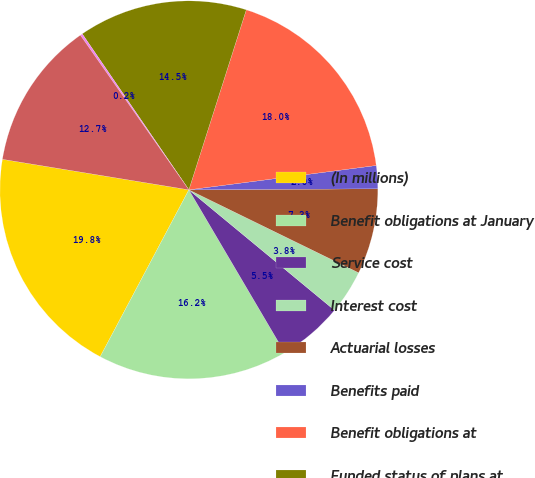Convert chart. <chart><loc_0><loc_0><loc_500><loc_500><pie_chart><fcel>(In millions)<fcel>Benefit obligations at January<fcel>Service cost<fcel>Interest cost<fcel>Actuarial losses<fcel>Benefits paid<fcel>Benefit obligations at<fcel>Funded status of plans at<fcel>Unrecognized prior service<fcel>Unrecognized net losses<nl><fcel>19.81%<fcel>16.24%<fcel>5.54%<fcel>3.76%<fcel>7.32%<fcel>1.97%<fcel>18.03%<fcel>14.46%<fcel>0.19%<fcel>12.68%<nl></chart> 